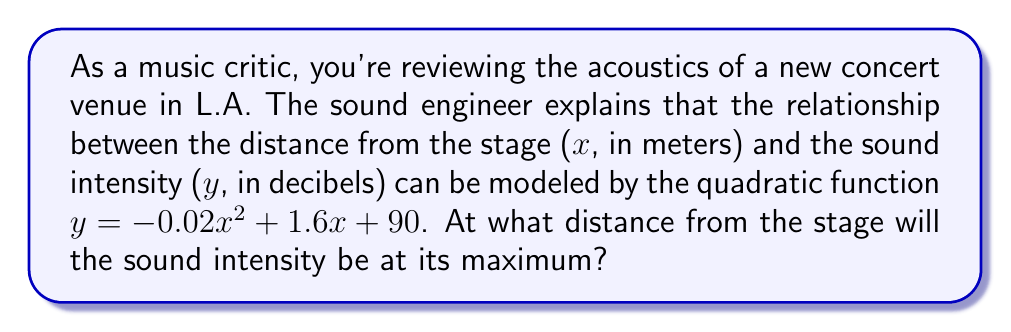Solve this math problem. To find the distance where the sound intensity is at its maximum, we need to follow these steps:

1) The given quadratic function is in the form $y = ax^2 + bx + c$, where:
   $a = -0.02$
   $b = 1.6$
   $c = 90$

2) For a quadratic function, the x-coordinate of the vertex represents the point where y is at its maximum (when $a < 0$) or minimum (when $a > 0$).

3) The formula for the x-coordinate of the vertex is:
   $x = -\frac{b}{2a}$

4) Substituting our values:
   $x = -\frac{1.6}{2(-0.02)}$

5) Simplifying:
   $x = -\frac{1.6}{-0.04} = 40$

Therefore, the sound intensity will be at its maximum 40 meters from the stage.
Answer: 40 meters 